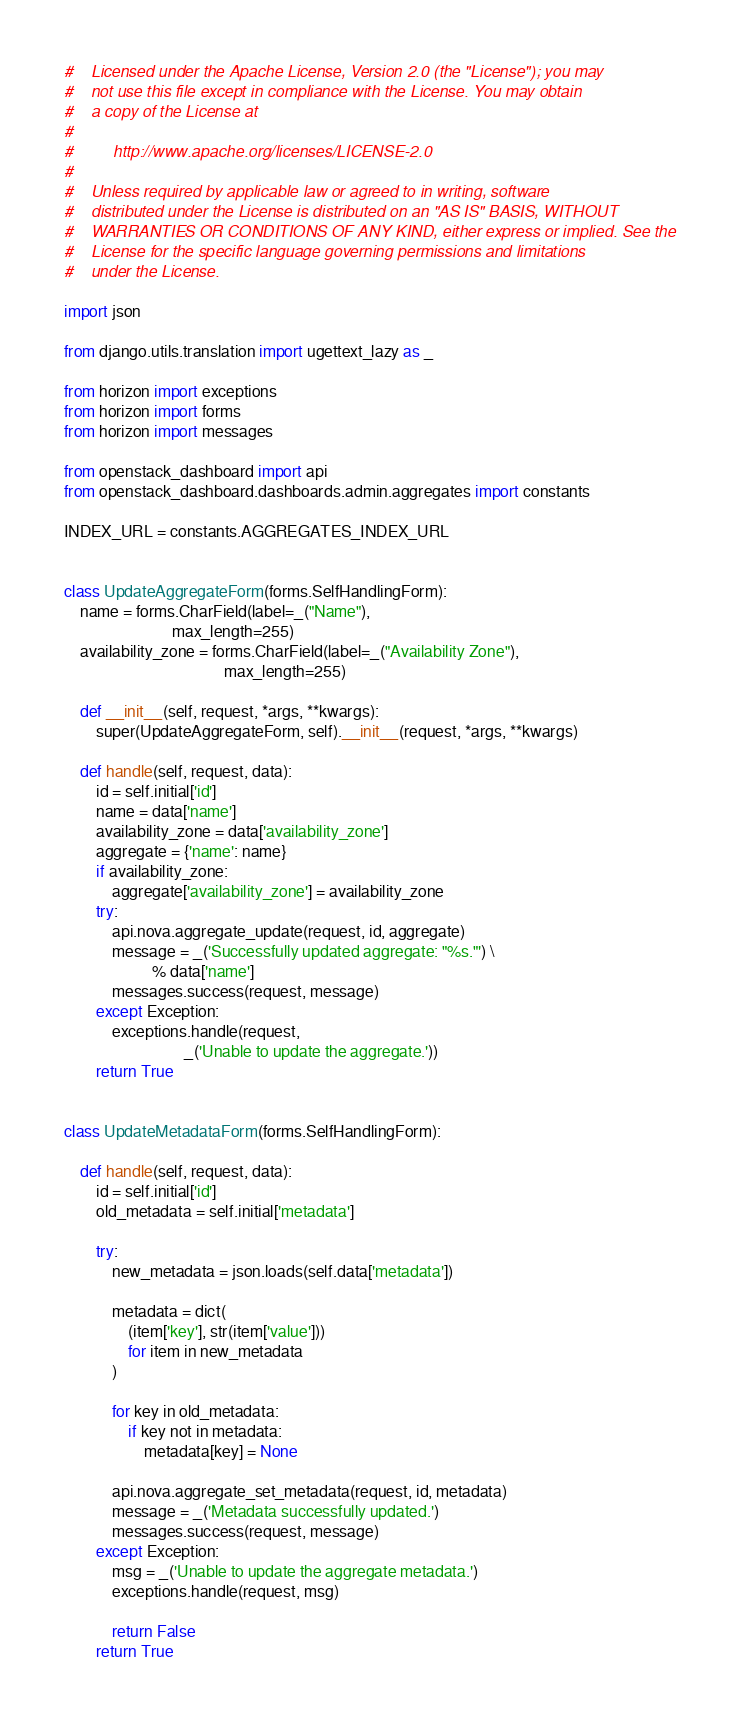<code> <loc_0><loc_0><loc_500><loc_500><_Python_>#    Licensed under the Apache License, Version 2.0 (the "License"); you may
#    not use this file except in compliance with the License. You may obtain
#    a copy of the License at
#
#         http://www.apache.org/licenses/LICENSE-2.0
#
#    Unless required by applicable law or agreed to in writing, software
#    distributed under the License is distributed on an "AS IS" BASIS, WITHOUT
#    WARRANTIES OR CONDITIONS OF ANY KIND, either express or implied. See the
#    License for the specific language governing permissions and limitations
#    under the License.

import json

from django.utils.translation import ugettext_lazy as _

from horizon import exceptions
from horizon import forms
from horizon import messages

from openstack_dashboard import api
from openstack_dashboard.dashboards.admin.aggregates import constants

INDEX_URL = constants.AGGREGATES_INDEX_URL


class UpdateAggregateForm(forms.SelfHandlingForm):
    name = forms.CharField(label=_("Name"),
                           max_length=255)
    availability_zone = forms.CharField(label=_("Availability Zone"),
                                        max_length=255)

    def __init__(self, request, *args, **kwargs):
        super(UpdateAggregateForm, self).__init__(request, *args, **kwargs)

    def handle(self, request, data):
        id = self.initial['id']
        name = data['name']
        availability_zone = data['availability_zone']
        aggregate = {'name': name}
        if availability_zone:
            aggregate['availability_zone'] = availability_zone
        try:
            api.nova.aggregate_update(request, id, aggregate)
            message = _('Successfully updated aggregate: "%s."') \
                      % data['name']
            messages.success(request, message)
        except Exception:
            exceptions.handle(request,
                              _('Unable to update the aggregate.'))
        return True


class UpdateMetadataForm(forms.SelfHandlingForm):

    def handle(self, request, data):
        id = self.initial['id']
        old_metadata = self.initial['metadata']

        try:
            new_metadata = json.loads(self.data['metadata'])

            metadata = dict(
                (item['key'], str(item['value']))
                for item in new_metadata
            )

            for key in old_metadata:
                if key not in metadata:
                    metadata[key] = None

            api.nova.aggregate_set_metadata(request, id, metadata)
            message = _('Metadata successfully updated.')
            messages.success(request, message)
        except Exception:
            msg = _('Unable to update the aggregate metadata.')
            exceptions.handle(request, msg)

            return False
        return True
</code> 